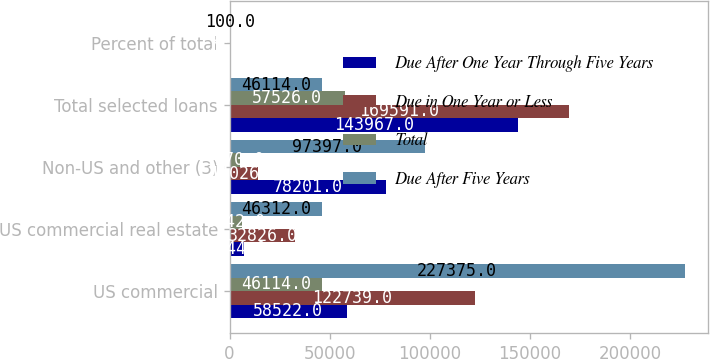Convert chart. <chart><loc_0><loc_0><loc_500><loc_500><stacked_bar_chart><ecel><fcel>US commercial<fcel>US commercial real estate<fcel>Non-US and other (3)<fcel>Total selected loans<fcel>Percent of total<nl><fcel>Due After One Year Through Five Years<fcel>58522<fcel>7244<fcel>78201<fcel>143967<fcel>39<nl><fcel>Due in One Year or Less<fcel>122739<fcel>32826<fcel>14026<fcel>169591<fcel>46<nl><fcel>Total<fcel>46114<fcel>6242<fcel>5170<fcel>57526<fcel>15<nl><fcel>Due After Five Years<fcel>227375<fcel>46312<fcel>97397<fcel>46114<fcel>100<nl></chart> 